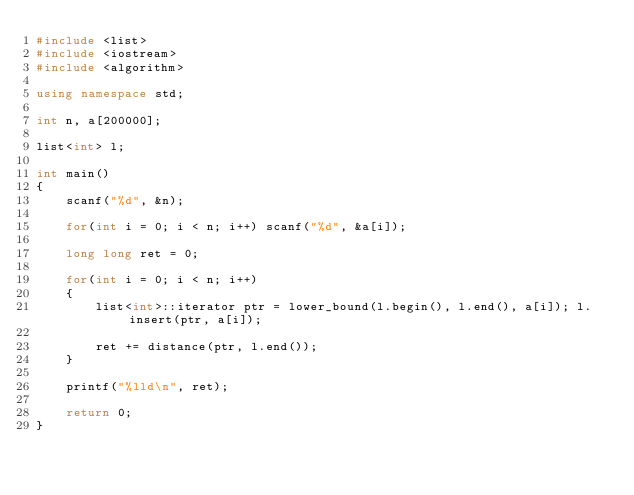Convert code to text. <code><loc_0><loc_0><loc_500><loc_500><_C++_>#include <list>
#include <iostream>
#include <algorithm>

using namespace std;

int n, a[200000];

list<int> l;

int main()
{
    scanf("%d", &n);
    
    for(int i = 0; i < n; i++) scanf("%d", &a[i]);
    
    long long ret = 0;
    
    for(int i = 0; i < n; i++)
    {
        list<int>::iterator ptr = lower_bound(l.begin(), l.end(), a[i]); l.insert(ptr, a[i]);
        
        ret += distance(ptr, l.end());
    }
    
    printf("%lld\n", ret);
    
    return 0;
}</code> 